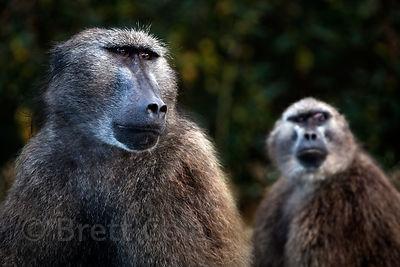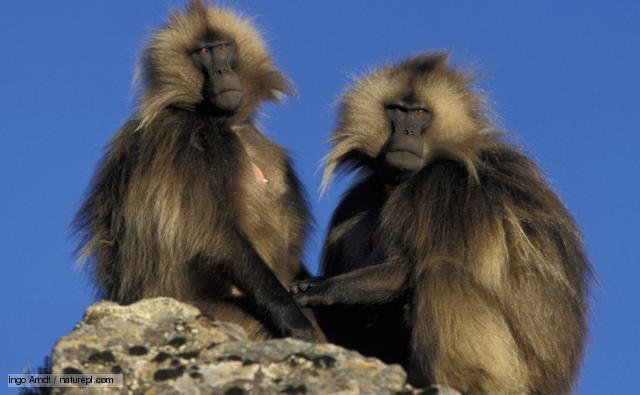The first image is the image on the left, the second image is the image on the right. Considering the images on both sides, is "There are at least three animals in the image on the left." valid? Answer yes or no. No. The first image is the image on the left, the second image is the image on the right. Examine the images to the left and right. Is the description "There is no more than two baboons in the left image." accurate? Answer yes or no. Yes. 